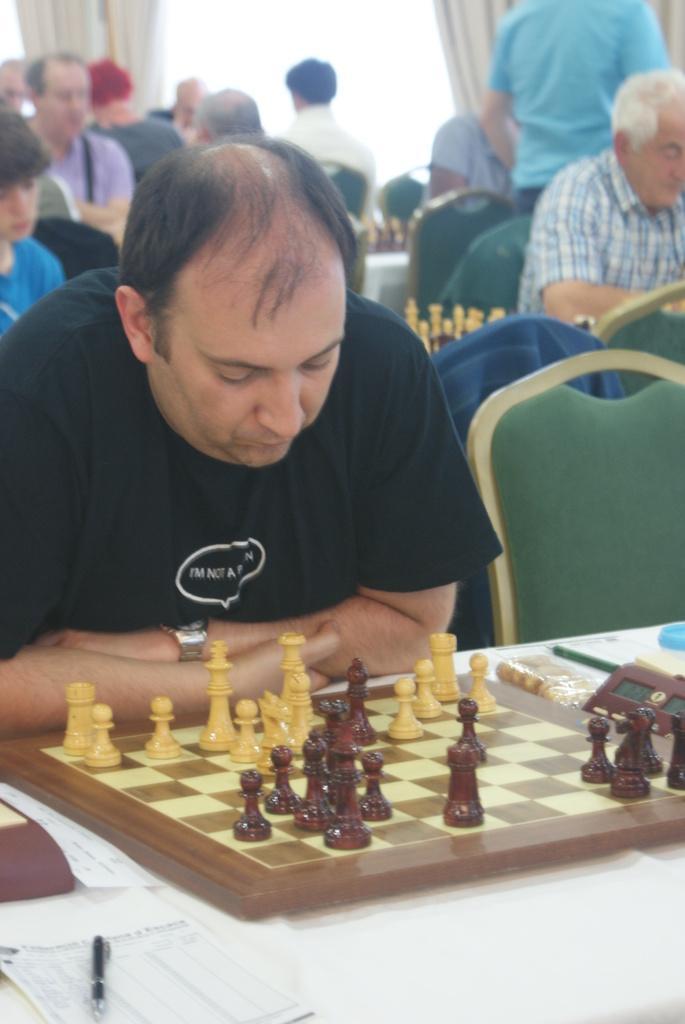How would you summarize this image in a sentence or two? Few persons are sitting on the chair and this person standing. We can see chess board,paper,pen and few things on the table. On the background we can see curtain. 